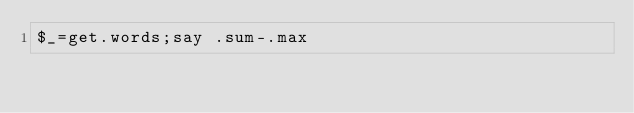<code> <loc_0><loc_0><loc_500><loc_500><_Perl_>$_=get.words;say .sum-.max</code> 